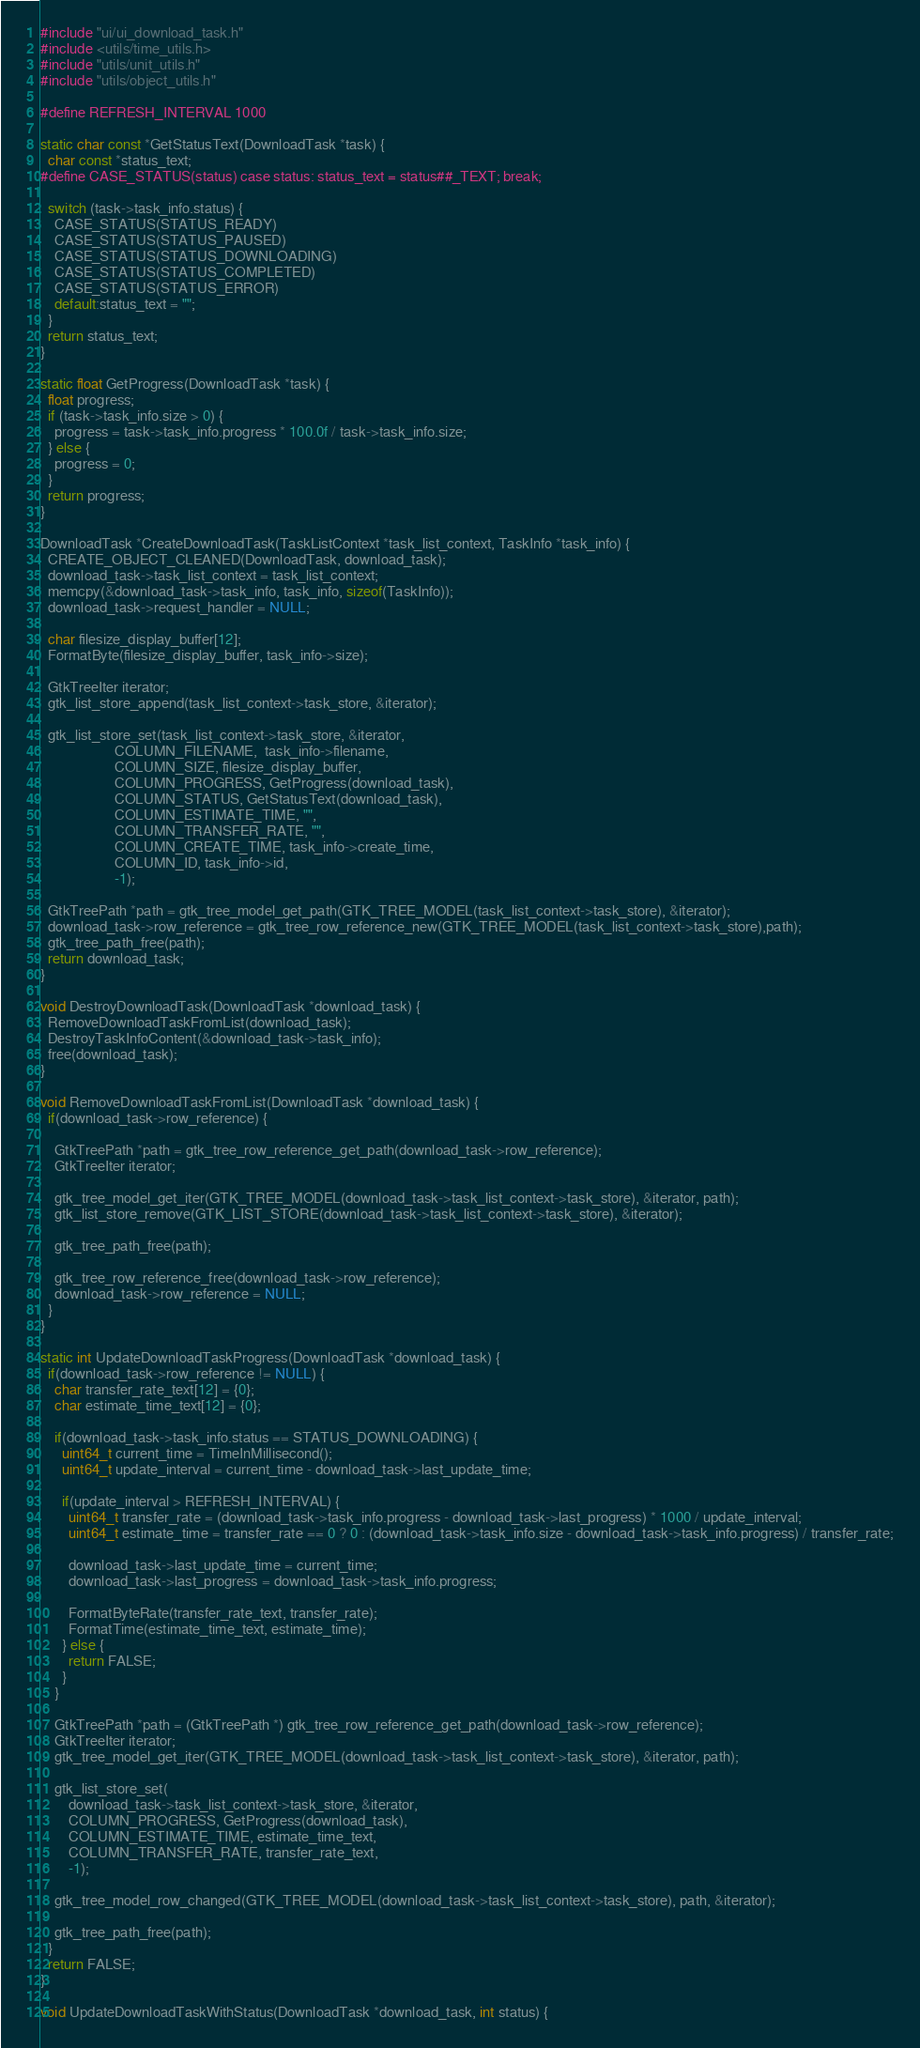Convert code to text. <code><loc_0><loc_0><loc_500><loc_500><_C_>#include "ui/ui_download_task.h"
#include <utils/time_utils.h>
#include "utils/unit_utils.h"
#include "utils/object_utils.h"

#define REFRESH_INTERVAL 1000

static char const *GetStatusText(DownloadTask *task) {
  char const *status_text;
#define CASE_STATUS(status) case status: status_text = status##_TEXT; break;

  switch (task->task_info.status) {
    CASE_STATUS(STATUS_READY)
    CASE_STATUS(STATUS_PAUSED)
    CASE_STATUS(STATUS_DOWNLOADING)
    CASE_STATUS(STATUS_COMPLETED)
    CASE_STATUS(STATUS_ERROR)
    default:status_text = "";
  }
  return status_text;
}

static float GetProgress(DownloadTask *task) {
  float progress;
  if (task->task_info.size > 0) {
    progress = task->task_info.progress * 100.0f / task->task_info.size;
  } else {
    progress = 0;
  }
  return progress;
}

DownloadTask *CreateDownloadTask(TaskListContext *task_list_context, TaskInfo *task_info) {
  CREATE_OBJECT_CLEANED(DownloadTask, download_task);
  download_task->task_list_context = task_list_context;
  memcpy(&download_task->task_info, task_info, sizeof(TaskInfo));
  download_task->request_handler = NULL;

  char filesize_display_buffer[12];
  FormatByte(filesize_display_buffer, task_info->size);

  GtkTreeIter iterator;
  gtk_list_store_append(task_list_context->task_store, &iterator);

  gtk_list_store_set(task_list_context->task_store, &iterator,
                     COLUMN_FILENAME,  task_info->filename,
                     COLUMN_SIZE, filesize_display_buffer,
                     COLUMN_PROGRESS, GetProgress(download_task),
                     COLUMN_STATUS, GetStatusText(download_task),
                     COLUMN_ESTIMATE_TIME, "",
                     COLUMN_TRANSFER_RATE, "",
                     COLUMN_CREATE_TIME, task_info->create_time,
                     COLUMN_ID, task_info->id,
                     -1);

  GtkTreePath *path = gtk_tree_model_get_path(GTK_TREE_MODEL(task_list_context->task_store), &iterator);
  download_task->row_reference = gtk_tree_row_reference_new(GTK_TREE_MODEL(task_list_context->task_store),path);
  gtk_tree_path_free(path);
  return download_task;
}

void DestroyDownloadTask(DownloadTask *download_task) {
  RemoveDownloadTaskFromList(download_task);
  DestroyTaskInfoContent(&download_task->task_info);
  free(download_task);
}

void RemoveDownloadTaskFromList(DownloadTask *download_task) {
  if(download_task->row_reference) {

    GtkTreePath *path = gtk_tree_row_reference_get_path(download_task->row_reference);
    GtkTreeIter iterator;

    gtk_tree_model_get_iter(GTK_TREE_MODEL(download_task->task_list_context->task_store), &iterator, path);
    gtk_list_store_remove(GTK_LIST_STORE(download_task->task_list_context->task_store), &iterator);

    gtk_tree_path_free(path);

    gtk_tree_row_reference_free(download_task->row_reference);
    download_task->row_reference = NULL;
  }
}

static int UpdateDownloadTaskProgress(DownloadTask *download_task) {
  if(download_task->row_reference != NULL) {
    char transfer_rate_text[12] = {0};
    char estimate_time_text[12] = {0};

    if(download_task->task_info.status == STATUS_DOWNLOADING) {
      uint64_t current_time = TimeInMillisecond();
      uint64_t update_interval = current_time - download_task->last_update_time;

      if(update_interval > REFRESH_INTERVAL) {
        uint64_t transfer_rate = (download_task->task_info.progress - download_task->last_progress) * 1000 / update_interval;
        uint64_t estimate_time = transfer_rate == 0 ? 0 : (download_task->task_info.size - download_task->task_info.progress) / transfer_rate;

        download_task->last_update_time = current_time;
        download_task->last_progress = download_task->task_info.progress;

        FormatByteRate(transfer_rate_text, transfer_rate);
        FormatTime(estimate_time_text, estimate_time);
      } else {
        return FALSE;
      }
    }

    GtkTreePath *path = (GtkTreePath *) gtk_tree_row_reference_get_path(download_task->row_reference);
    GtkTreeIter iterator;
    gtk_tree_model_get_iter(GTK_TREE_MODEL(download_task->task_list_context->task_store), &iterator, path);

    gtk_list_store_set(
        download_task->task_list_context->task_store, &iterator,
        COLUMN_PROGRESS, GetProgress(download_task),
        COLUMN_ESTIMATE_TIME, estimate_time_text,
        COLUMN_TRANSFER_RATE, transfer_rate_text,
        -1);

    gtk_tree_model_row_changed(GTK_TREE_MODEL(download_task->task_list_context->task_store), path, &iterator);

    gtk_tree_path_free(path);
  }
  return FALSE;
}

void UpdateDownloadTaskWithStatus(DownloadTask *download_task, int status) {</code> 